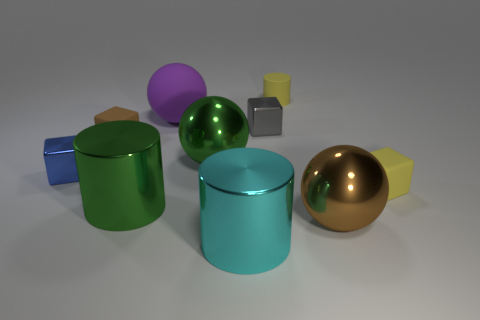Are there more tiny things that are left of the big purple object than brown metal objects?
Keep it short and to the point. Yes. Are the brown block and the gray cube made of the same material?
Offer a terse response. No. How many things are either brown things that are on the left side of the big cyan shiny cylinder or spheres?
Your answer should be very brief. 4. How many other objects are the same size as the brown metallic sphere?
Your answer should be very brief. 4. Are there the same number of brown spheres that are on the left side of the tiny brown object and cylinders that are in front of the cyan metal cylinder?
Keep it short and to the point. Yes. The other shiny object that is the same shape as the big brown object is what color?
Ensure brevity in your answer.  Green. Are there any other things that are the same shape as the gray metallic object?
Your answer should be very brief. Yes. There is a matte cube that is right of the tiny gray block; is its color the same as the matte cylinder?
Make the answer very short. Yes. What size is the brown thing that is the same shape as the large purple rubber thing?
Make the answer very short. Large. What number of large brown balls are made of the same material as the small blue object?
Give a very brief answer. 1. 